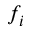Convert formula to latex. <formula><loc_0><loc_0><loc_500><loc_500>f _ { i }</formula> 